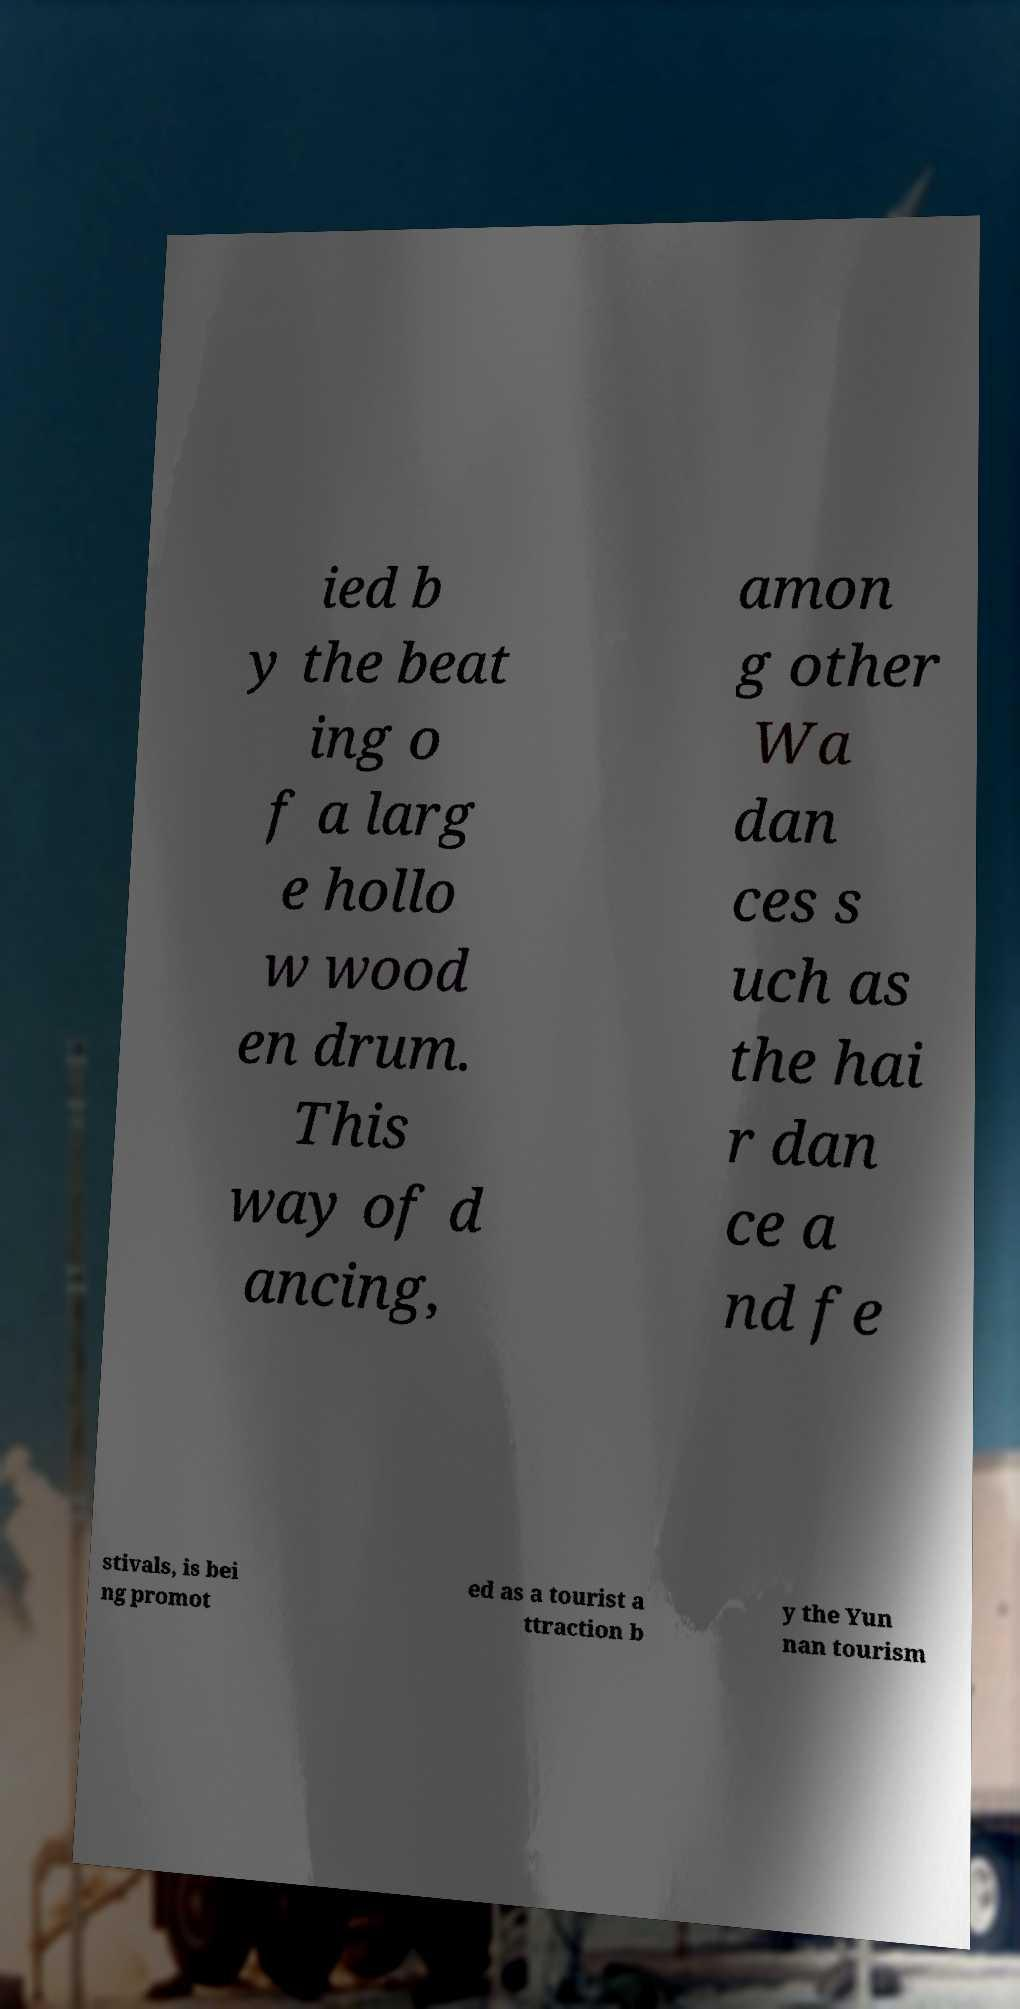Can you accurately transcribe the text from the provided image for me? ied b y the beat ing o f a larg e hollo w wood en drum. This way of d ancing, amon g other Wa dan ces s uch as the hai r dan ce a nd fe stivals, is bei ng promot ed as a tourist a ttraction b y the Yun nan tourism 